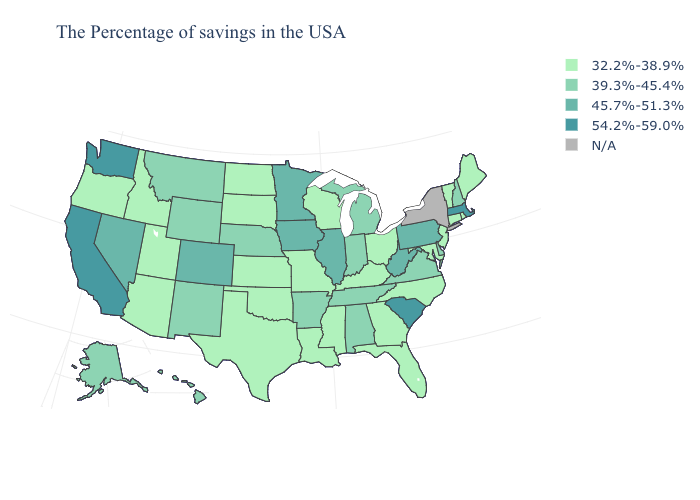Does the map have missing data?
Concise answer only. Yes. What is the value of Kentucky?
Short answer required. 32.2%-38.9%. Does Texas have the lowest value in the South?
Answer briefly. Yes. What is the highest value in the USA?
Short answer required. 54.2%-59.0%. What is the value of Missouri?
Quick response, please. 32.2%-38.9%. Does Illinois have the highest value in the MidWest?
Write a very short answer. Yes. Among the states that border Michigan , which have the lowest value?
Write a very short answer. Ohio, Wisconsin. What is the lowest value in the Northeast?
Quick response, please. 32.2%-38.9%. Does the first symbol in the legend represent the smallest category?
Concise answer only. Yes. Among the states that border Ohio , which have the highest value?
Write a very short answer. Pennsylvania, West Virginia. What is the lowest value in the USA?
Concise answer only. 32.2%-38.9%. What is the value of Indiana?
Quick response, please. 39.3%-45.4%. Among the states that border North Dakota , which have the lowest value?
Short answer required. South Dakota. Name the states that have a value in the range 54.2%-59.0%?
Concise answer only. Massachusetts, South Carolina, California, Washington. Name the states that have a value in the range 45.7%-51.3%?
Give a very brief answer. Pennsylvania, West Virginia, Illinois, Minnesota, Iowa, Colorado, Nevada. 